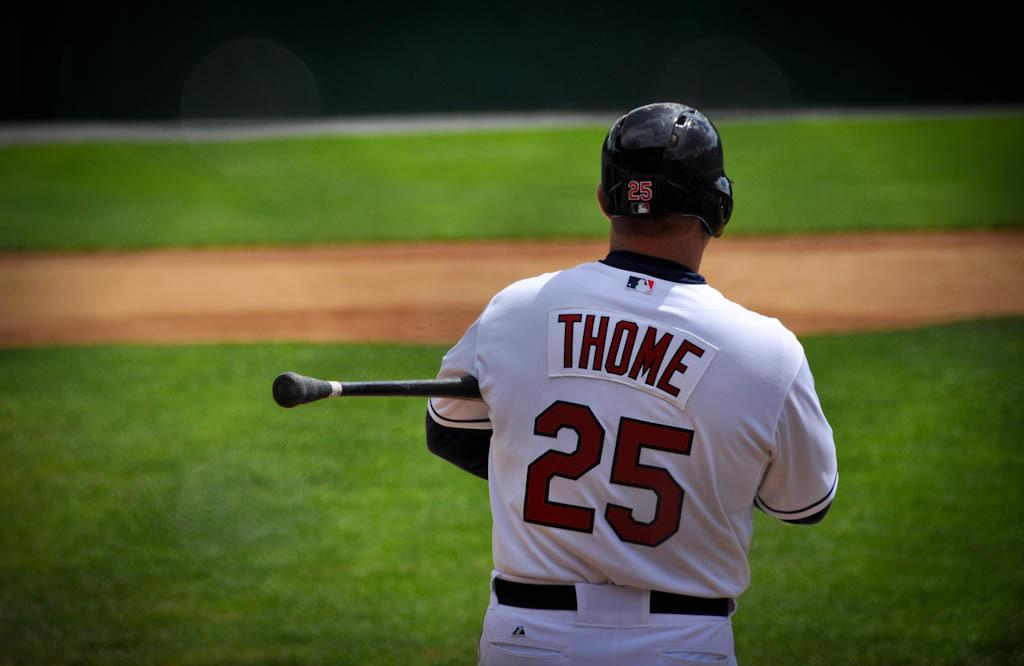Who is present in the image? There is a man in the image. What is the man wearing on his head? The man is wearing a helmet. What is the man wearing on his body? The man is wearing a white dress. What is the man holding in his hand? The man is holding a black color stick. What can be seen in the background of the image? There is grass in the background of the image. Where is the bomb hidden in the image? There is no bomb present in the image. What type of cork can be seen in the man's hand? The man is holding a black color stick, not a cork, in his hand. 